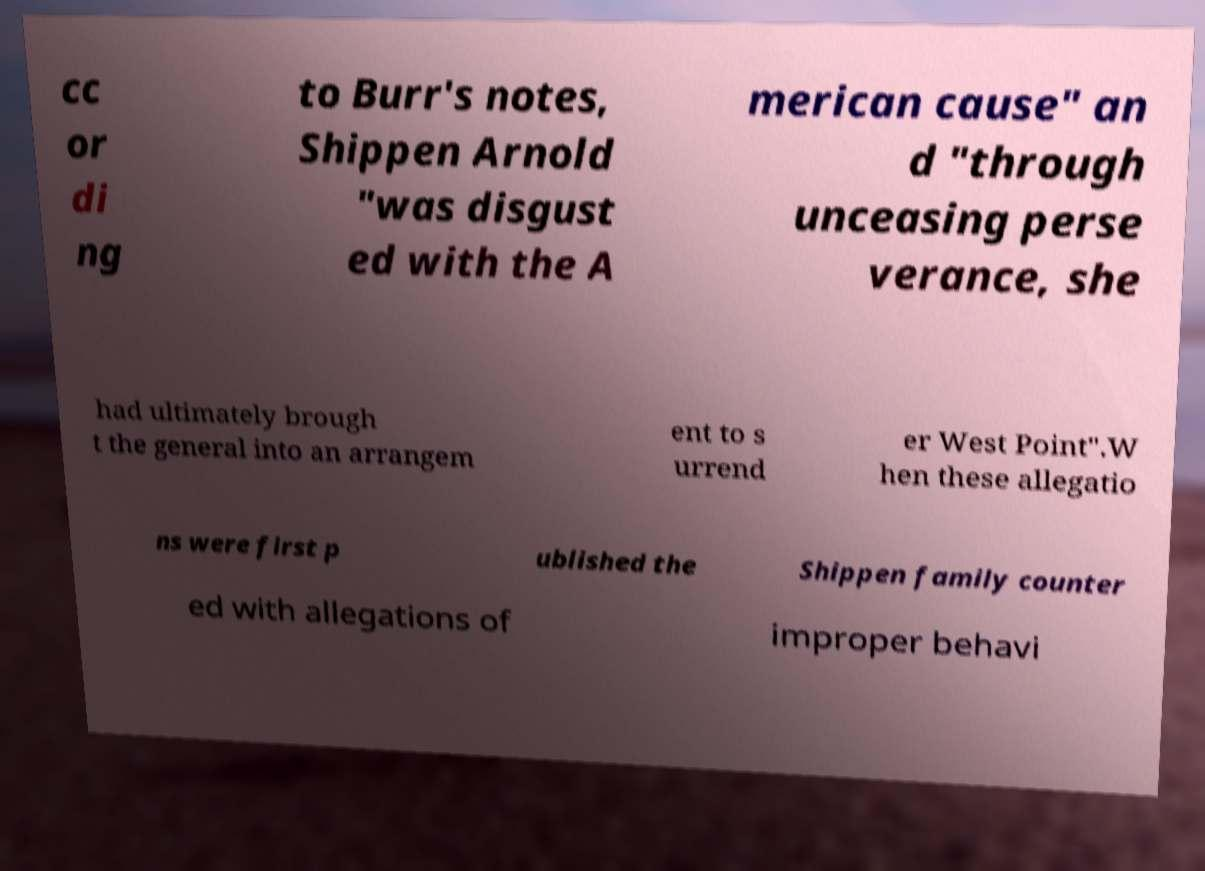What messages or text are displayed in this image? I need them in a readable, typed format. cc or di ng to Burr's notes, Shippen Arnold "was disgust ed with the A merican cause" an d "through unceasing perse verance, she had ultimately brough t the general into an arrangem ent to s urrend er West Point".W hen these allegatio ns were first p ublished the Shippen family counter ed with allegations of improper behavi 